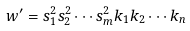Convert formula to latex. <formula><loc_0><loc_0><loc_500><loc_500>w ^ { \prime } = s ^ { 2 } _ { 1 } s ^ { 2 } _ { 2 } \cdots s ^ { 2 } _ { m } k _ { 1 } k _ { 2 } \cdots k _ { n }</formula> 